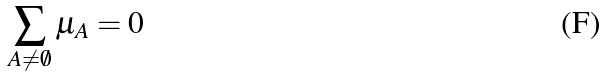Convert formula to latex. <formula><loc_0><loc_0><loc_500><loc_500>\sum _ { A \neq \emptyset } \mu _ { A } = 0</formula> 